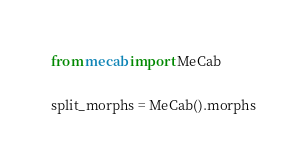<code> <loc_0><loc_0><loc_500><loc_500><_Python_>from mecab import MeCab

split_morphs = MeCab().morphs
</code> 